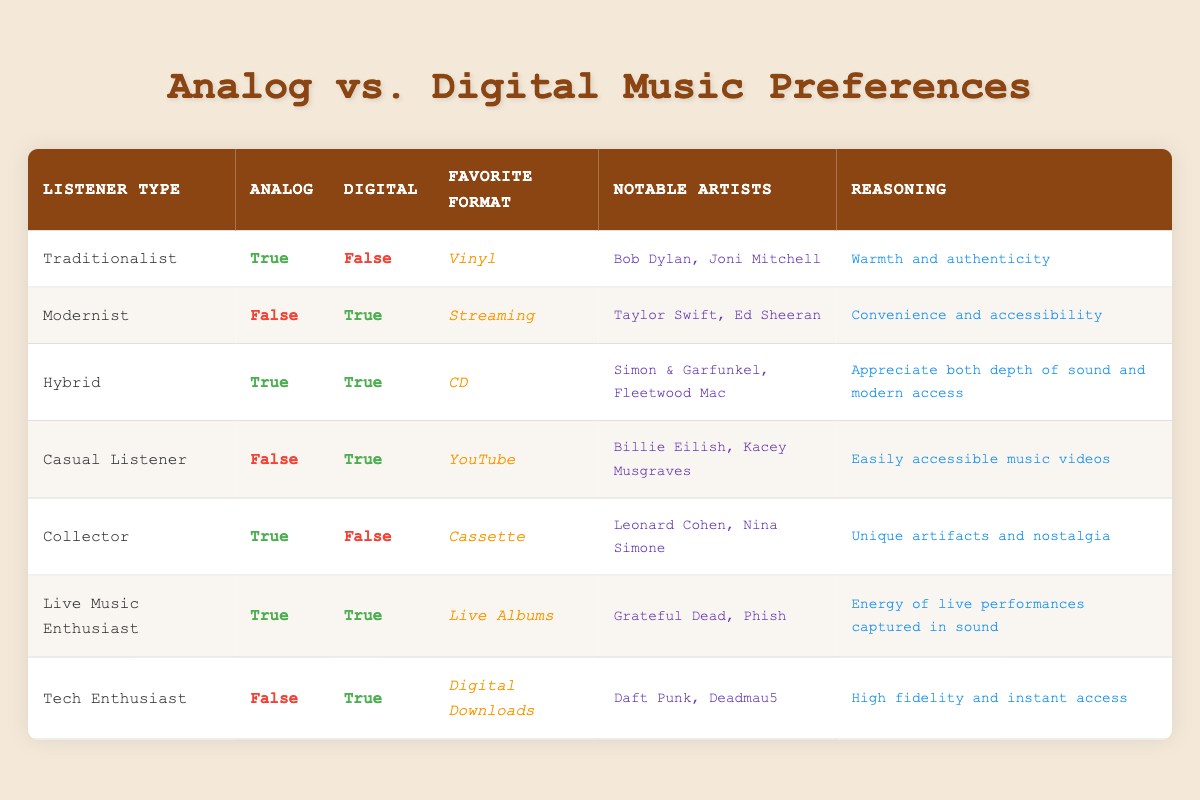What is the favorite format of the Traditionalist listener? The table indicates that the favorite format of the Traditionalist listener is "Vinyl." This can be found in the corresponding row for the listener type Traditionalist.
Answer: Vinyl How many listeners prefer digital music over analog music? By examining the table, we see that the Modernist, Casual Listener, and Tech Enthusiast prefer only digital music, totaling 3 listeners. Therefore, when counting these specific types, the answer is 3.
Answer: 3 Is there any listener type that prefers both analog and digital formats? The table shows that both the Hybrid and Live Music Enthusiast listener types prefer both analog and digital formats. The Hybrid and Live Music Enthusiast rows show "True" for both analog and digital preferences.
Answer: Yes Which notable artists are favored by the Collector listener type? According to the table, the notable artists mentioned for the Collector listener type are "Leonard Cohen, Nina Simone." These artists are listed in the Collector's row.
Answer: Leonard Cohen, Nina Simone What reasoning is given by the Hybrid listener for their preferences? In the row for the Hybrid listener type, the reasoning provided is "Appreciate both depth of sound and modern access." This is stated in the same row under the reasoning column.
Answer: Appreciate both depth of sound and modern access Which listener type has the highest preference for analog music? The listener types that have an analog preference are Traditionalist, Hybrid, Collector, and Live Music Enthusiast. Since all four are given as true, they indicate the highest preference for analog music.
Answer: 4 How many notable artists are mentioned for each listener type that prefers only digital formats? The Digital formats are preferred by the Modernist, Casual Listener, and Tech Enthusiast. Counting their notable artists yields "Taylor Swift, Ed Sheeran," "Billie Eilish, Kacey Musgraves," and "Daft Punk, Deadmau5," totaling 6 notable artists.
Answer: 6 Is the reasoning for the Casual Listener based on music accessibility? The reasoning for the Casual Listener in the table is "Easily accessible music videos," which directly indicates that their reasoning is based on accessibility. This confirms the answer of yes.
Answer: Yes What preference do both the Hybrid and Live Music Enthusiast listener types share? Both the Hybrid and Live Music Enthusiast listeners share preferences for analog music as marked "True" in the table for both. They also have the common aspect of enjoying modern access and live performance energy.
Answer: They both prefer analog music 